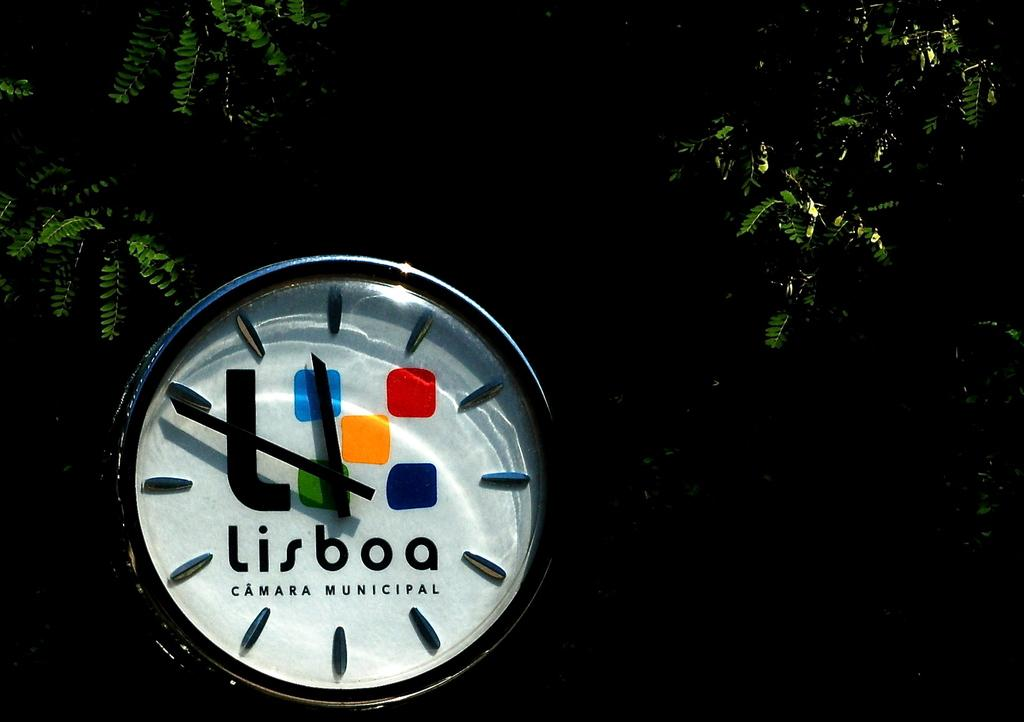<image>
Describe the image concisely. A clock face has a logo Lisboa under its hands. 